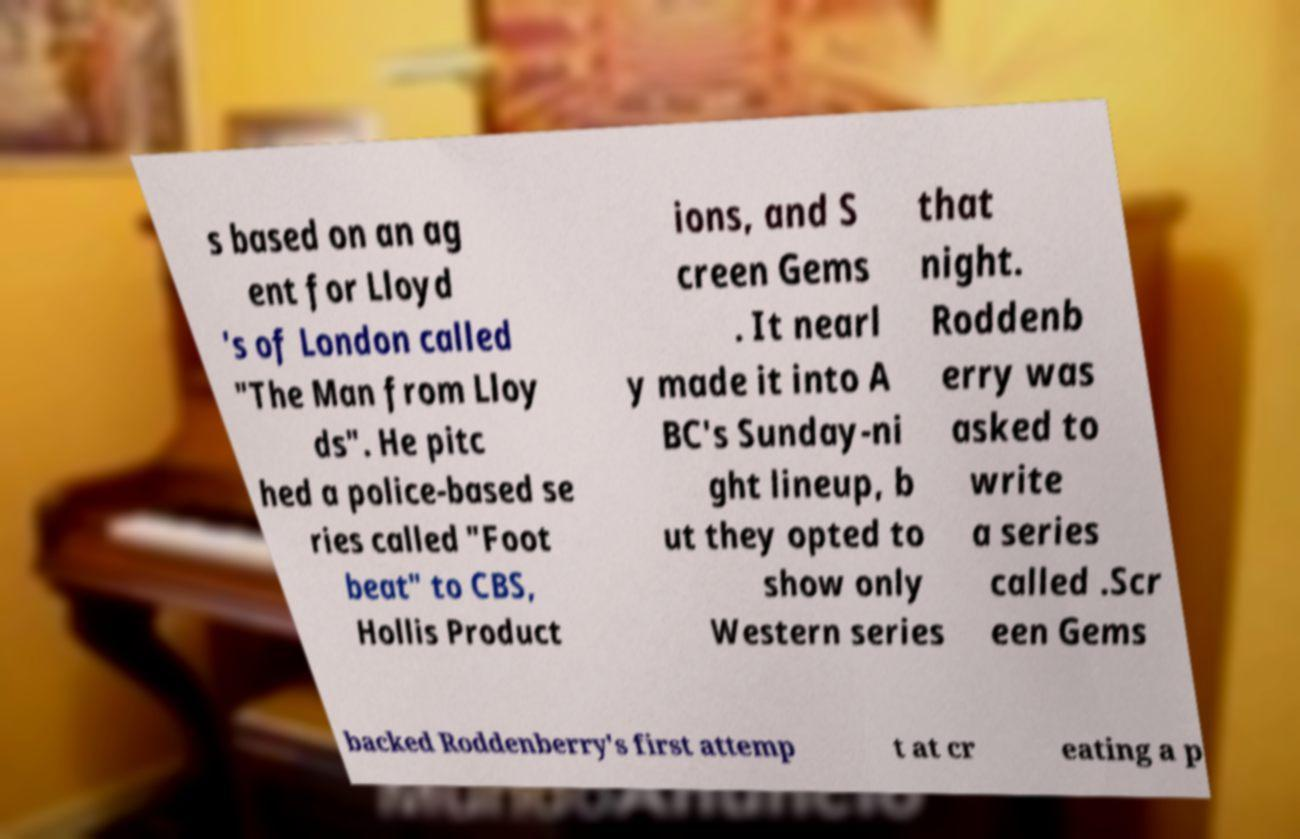Could you assist in decoding the text presented in this image and type it out clearly? s based on an ag ent for Lloyd 's of London called "The Man from Lloy ds". He pitc hed a police-based se ries called "Foot beat" to CBS, Hollis Product ions, and S creen Gems . It nearl y made it into A BC's Sunday-ni ght lineup, b ut they opted to show only Western series that night. Roddenb erry was asked to write a series called .Scr een Gems backed Roddenberry's first attemp t at cr eating a p 